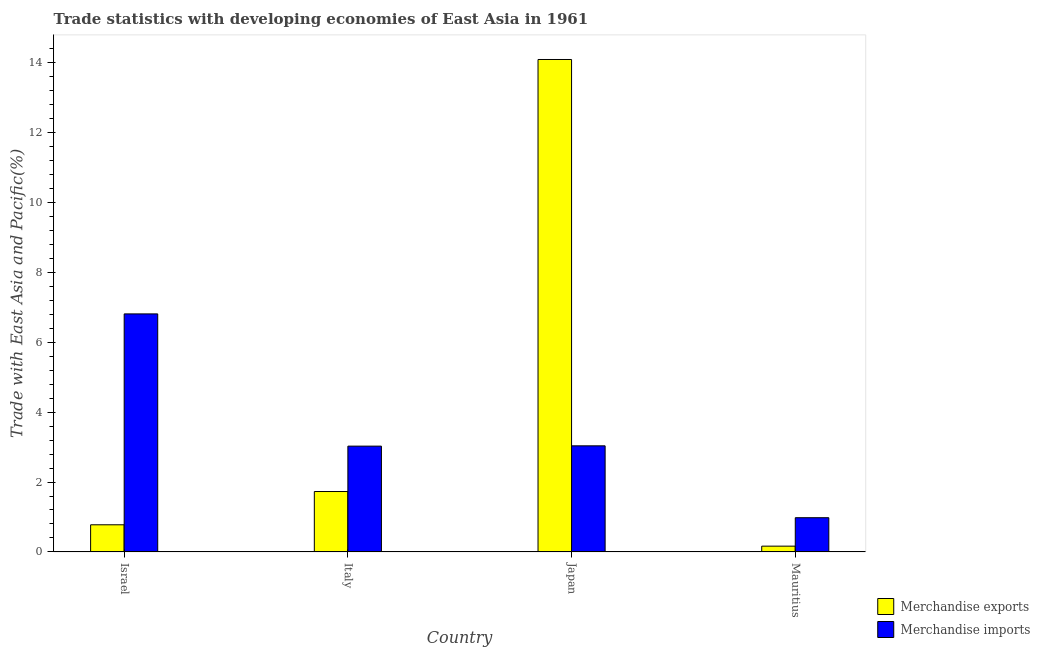How many different coloured bars are there?
Offer a very short reply. 2. Are the number of bars per tick equal to the number of legend labels?
Give a very brief answer. Yes. How many bars are there on the 1st tick from the left?
Your answer should be very brief. 2. What is the label of the 4th group of bars from the left?
Provide a succinct answer. Mauritius. In how many cases, is the number of bars for a given country not equal to the number of legend labels?
Offer a very short reply. 0. What is the merchandise exports in Japan?
Offer a very short reply. 14.09. Across all countries, what is the maximum merchandise imports?
Make the answer very short. 6.81. Across all countries, what is the minimum merchandise imports?
Provide a succinct answer. 0.98. In which country was the merchandise exports minimum?
Keep it short and to the point. Mauritius. What is the total merchandise imports in the graph?
Your answer should be very brief. 13.85. What is the difference between the merchandise exports in Italy and that in Mauritius?
Offer a very short reply. 1.56. What is the difference between the merchandise exports in Israel and the merchandise imports in Japan?
Your response must be concise. -2.26. What is the average merchandise exports per country?
Ensure brevity in your answer.  4.19. What is the difference between the merchandise imports and merchandise exports in Israel?
Offer a very short reply. 6.03. In how many countries, is the merchandise exports greater than 13.2 %?
Offer a terse response. 1. What is the ratio of the merchandise exports in Italy to that in Japan?
Provide a short and direct response. 0.12. Is the merchandise imports in Italy less than that in Mauritius?
Provide a succinct answer. No. What is the difference between the highest and the second highest merchandise exports?
Keep it short and to the point. 12.36. What is the difference between the highest and the lowest merchandise imports?
Your response must be concise. 5.83. In how many countries, is the merchandise imports greater than the average merchandise imports taken over all countries?
Your response must be concise. 1. Is the sum of the merchandise imports in Israel and Italy greater than the maximum merchandise exports across all countries?
Provide a succinct answer. No. What does the 1st bar from the right in Mauritius represents?
Provide a succinct answer. Merchandise imports. How many bars are there?
Your answer should be compact. 8. How many countries are there in the graph?
Provide a short and direct response. 4. Does the graph contain grids?
Offer a terse response. No. How many legend labels are there?
Provide a succinct answer. 2. What is the title of the graph?
Give a very brief answer. Trade statistics with developing economies of East Asia in 1961. Does "Imports" appear as one of the legend labels in the graph?
Your answer should be very brief. No. What is the label or title of the Y-axis?
Give a very brief answer. Trade with East Asia and Pacific(%). What is the Trade with East Asia and Pacific(%) in Merchandise exports in Israel?
Keep it short and to the point. 0.78. What is the Trade with East Asia and Pacific(%) in Merchandise imports in Israel?
Make the answer very short. 6.81. What is the Trade with East Asia and Pacific(%) of Merchandise exports in Italy?
Your answer should be very brief. 1.73. What is the Trade with East Asia and Pacific(%) of Merchandise imports in Italy?
Your answer should be very brief. 3.03. What is the Trade with East Asia and Pacific(%) of Merchandise exports in Japan?
Your answer should be very brief. 14.09. What is the Trade with East Asia and Pacific(%) in Merchandise imports in Japan?
Your answer should be very brief. 3.03. What is the Trade with East Asia and Pacific(%) in Merchandise exports in Mauritius?
Your answer should be very brief. 0.17. What is the Trade with East Asia and Pacific(%) of Merchandise imports in Mauritius?
Offer a very short reply. 0.98. Across all countries, what is the maximum Trade with East Asia and Pacific(%) in Merchandise exports?
Your answer should be compact. 14.09. Across all countries, what is the maximum Trade with East Asia and Pacific(%) of Merchandise imports?
Your answer should be compact. 6.81. Across all countries, what is the minimum Trade with East Asia and Pacific(%) of Merchandise exports?
Give a very brief answer. 0.17. Across all countries, what is the minimum Trade with East Asia and Pacific(%) in Merchandise imports?
Provide a succinct answer. 0.98. What is the total Trade with East Asia and Pacific(%) in Merchandise exports in the graph?
Ensure brevity in your answer.  16.76. What is the total Trade with East Asia and Pacific(%) in Merchandise imports in the graph?
Ensure brevity in your answer.  13.85. What is the difference between the Trade with East Asia and Pacific(%) in Merchandise exports in Israel and that in Italy?
Your answer should be very brief. -0.95. What is the difference between the Trade with East Asia and Pacific(%) in Merchandise imports in Israel and that in Italy?
Provide a short and direct response. 3.78. What is the difference between the Trade with East Asia and Pacific(%) in Merchandise exports in Israel and that in Japan?
Your answer should be very brief. -13.31. What is the difference between the Trade with East Asia and Pacific(%) in Merchandise imports in Israel and that in Japan?
Keep it short and to the point. 3.77. What is the difference between the Trade with East Asia and Pacific(%) of Merchandise exports in Israel and that in Mauritius?
Provide a succinct answer. 0.61. What is the difference between the Trade with East Asia and Pacific(%) in Merchandise imports in Israel and that in Mauritius?
Your answer should be compact. 5.83. What is the difference between the Trade with East Asia and Pacific(%) of Merchandise exports in Italy and that in Japan?
Keep it short and to the point. -12.36. What is the difference between the Trade with East Asia and Pacific(%) of Merchandise imports in Italy and that in Japan?
Provide a short and direct response. -0.01. What is the difference between the Trade with East Asia and Pacific(%) of Merchandise exports in Italy and that in Mauritius?
Provide a short and direct response. 1.56. What is the difference between the Trade with East Asia and Pacific(%) of Merchandise imports in Italy and that in Mauritius?
Make the answer very short. 2.05. What is the difference between the Trade with East Asia and Pacific(%) of Merchandise exports in Japan and that in Mauritius?
Your answer should be very brief. 13.92. What is the difference between the Trade with East Asia and Pacific(%) of Merchandise imports in Japan and that in Mauritius?
Give a very brief answer. 2.06. What is the difference between the Trade with East Asia and Pacific(%) of Merchandise exports in Israel and the Trade with East Asia and Pacific(%) of Merchandise imports in Italy?
Make the answer very short. -2.25. What is the difference between the Trade with East Asia and Pacific(%) of Merchandise exports in Israel and the Trade with East Asia and Pacific(%) of Merchandise imports in Japan?
Offer a very short reply. -2.26. What is the difference between the Trade with East Asia and Pacific(%) in Merchandise exports in Israel and the Trade with East Asia and Pacific(%) in Merchandise imports in Mauritius?
Give a very brief answer. -0.2. What is the difference between the Trade with East Asia and Pacific(%) of Merchandise exports in Italy and the Trade with East Asia and Pacific(%) of Merchandise imports in Japan?
Make the answer very short. -1.31. What is the difference between the Trade with East Asia and Pacific(%) of Merchandise exports in Italy and the Trade with East Asia and Pacific(%) of Merchandise imports in Mauritius?
Keep it short and to the point. 0.75. What is the difference between the Trade with East Asia and Pacific(%) of Merchandise exports in Japan and the Trade with East Asia and Pacific(%) of Merchandise imports in Mauritius?
Offer a very short reply. 13.11. What is the average Trade with East Asia and Pacific(%) of Merchandise exports per country?
Your response must be concise. 4.19. What is the average Trade with East Asia and Pacific(%) of Merchandise imports per country?
Provide a succinct answer. 3.46. What is the difference between the Trade with East Asia and Pacific(%) of Merchandise exports and Trade with East Asia and Pacific(%) of Merchandise imports in Israel?
Give a very brief answer. -6.03. What is the difference between the Trade with East Asia and Pacific(%) in Merchandise exports and Trade with East Asia and Pacific(%) in Merchandise imports in Italy?
Your answer should be very brief. -1.3. What is the difference between the Trade with East Asia and Pacific(%) in Merchandise exports and Trade with East Asia and Pacific(%) in Merchandise imports in Japan?
Your answer should be compact. 11.05. What is the difference between the Trade with East Asia and Pacific(%) of Merchandise exports and Trade with East Asia and Pacific(%) of Merchandise imports in Mauritius?
Your response must be concise. -0.81. What is the ratio of the Trade with East Asia and Pacific(%) of Merchandise exports in Israel to that in Italy?
Your answer should be very brief. 0.45. What is the ratio of the Trade with East Asia and Pacific(%) of Merchandise imports in Israel to that in Italy?
Make the answer very short. 2.25. What is the ratio of the Trade with East Asia and Pacific(%) in Merchandise exports in Israel to that in Japan?
Your answer should be compact. 0.06. What is the ratio of the Trade with East Asia and Pacific(%) of Merchandise imports in Israel to that in Japan?
Keep it short and to the point. 2.24. What is the ratio of the Trade with East Asia and Pacific(%) of Merchandise exports in Israel to that in Mauritius?
Offer a terse response. 4.69. What is the ratio of the Trade with East Asia and Pacific(%) in Merchandise imports in Israel to that in Mauritius?
Give a very brief answer. 6.95. What is the ratio of the Trade with East Asia and Pacific(%) of Merchandise exports in Italy to that in Japan?
Offer a terse response. 0.12. What is the ratio of the Trade with East Asia and Pacific(%) in Merchandise exports in Italy to that in Mauritius?
Your answer should be compact. 10.44. What is the ratio of the Trade with East Asia and Pacific(%) in Merchandise imports in Italy to that in Mauritius?
Provide a short and direct response. 3.09. What is the ratio of the Trade with East Asia and Pacific(%) in Merchandise exports in Japan to that in Mauritius?
Your response must be concise. 85.07. What is the ratio of the Trade with East Asia and Pacific(%) of Merchandise imports in Japan to that in Mauritius?
Ensure brevity in your answer.  3.1. What is the difference between the highest and the second highest Trade with East Asia and Pacific(%) in Merchandise exports?
Your answer should be compact. 12.36. What is the difference between the highest and the second highest Trade with East Asia and Pacific(%) in Merchandise imports?
Provide a short and direct response. 3.77. What is the difference between the highest and the lowest Trade with East Asia and Pacific(%) in Merchandise exports?
Your answer should be very brief. 13.92. What is the difference between the highest and the lowest Trade with East Asia and Pacific(%) of Merchandise imports?
Give a very brief answer. 5.83. 